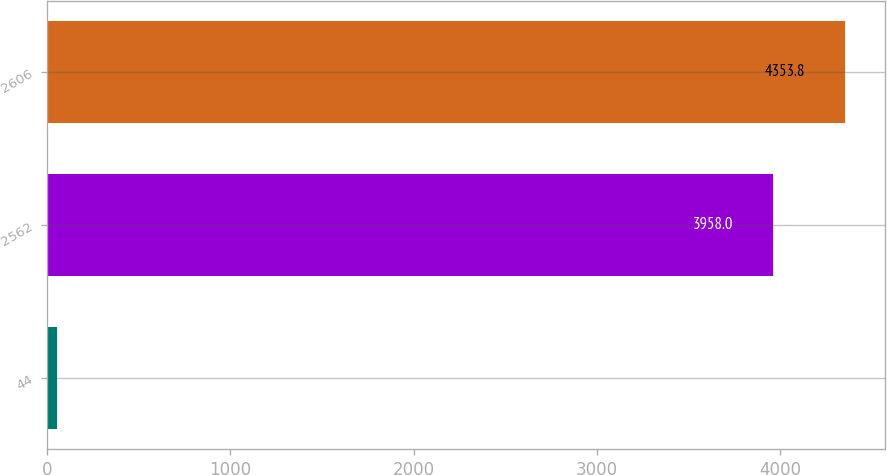Convert chart to OTSL. <chart><loc_0><loc_0><loc_500><loc_500><bar_chart><fcel>44<fcel>2562<fcel>2606<nl><fcel>54<fcel>3958<fcel>4353.8<nl></chart> 